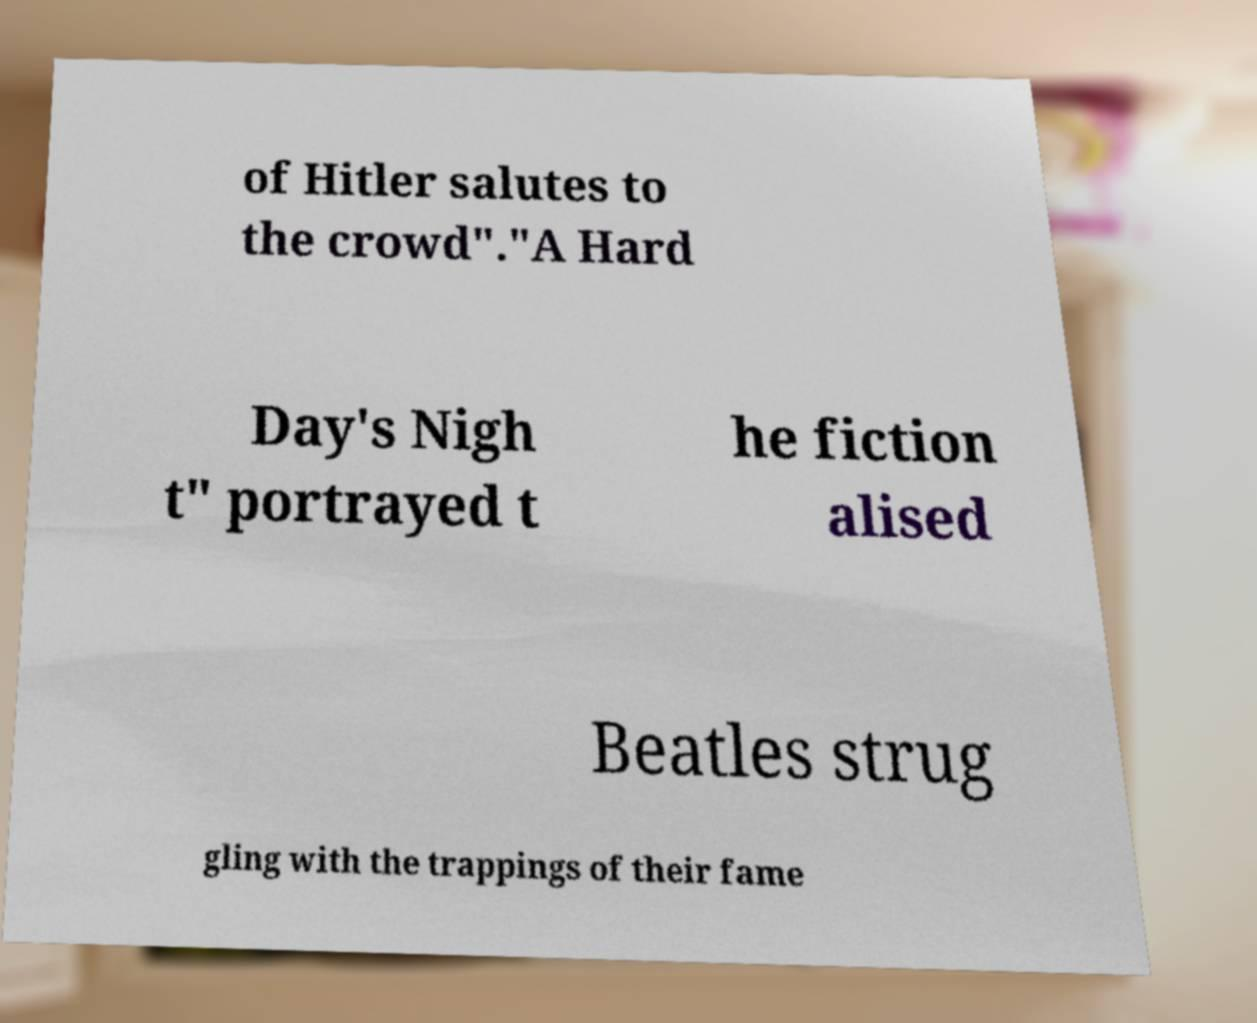Could you extract and type out the text from this image? of Hitler salutes to the crowd"."A Hard Day's Nigh t" portrayed t he fiction alised Beatles strug gling with the trappings of their fame 